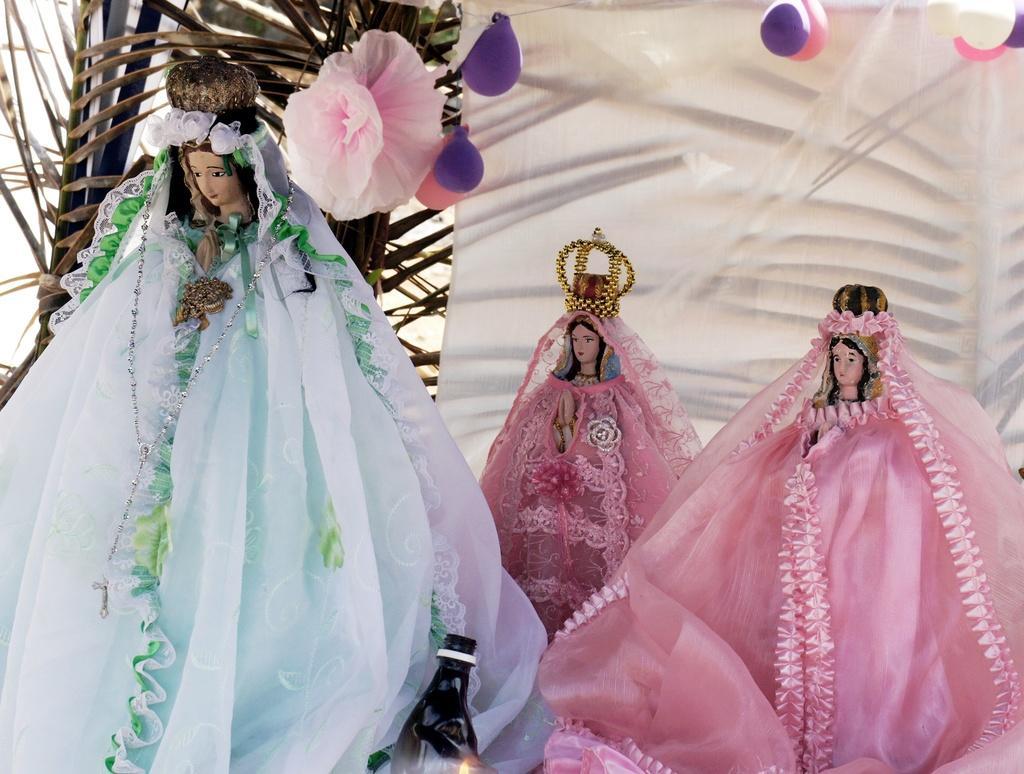In one or two sentences, can you explain what this image depicts? In this picture we can see three dolls. One dollar is wearing white and green color dress and the other two are wearing pink color dress. Behind them one curtain and balloon and flower is there. And one plant is present. 